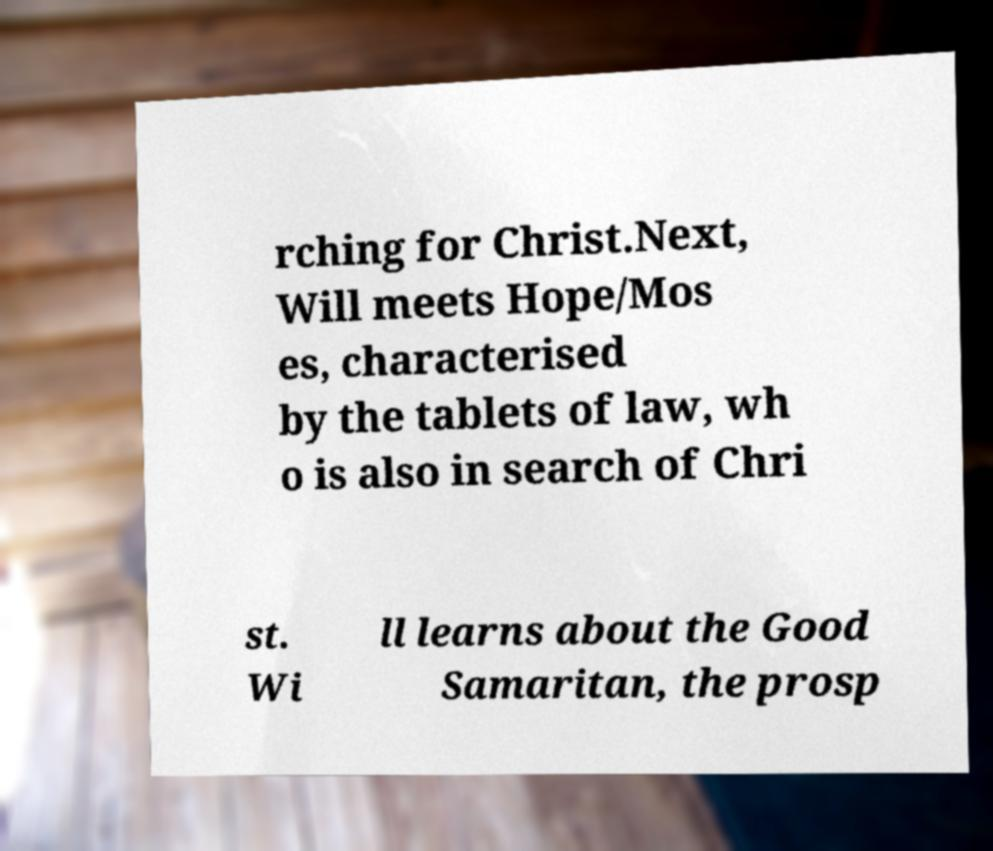Could you extract and type out the text from this image? rching for Christ.Next, Will meets Hope/Mos es, characterised by the tablets of law, wh o is also in search of Chri st. Wi ll learns about the Good Samaritan, the prosp 